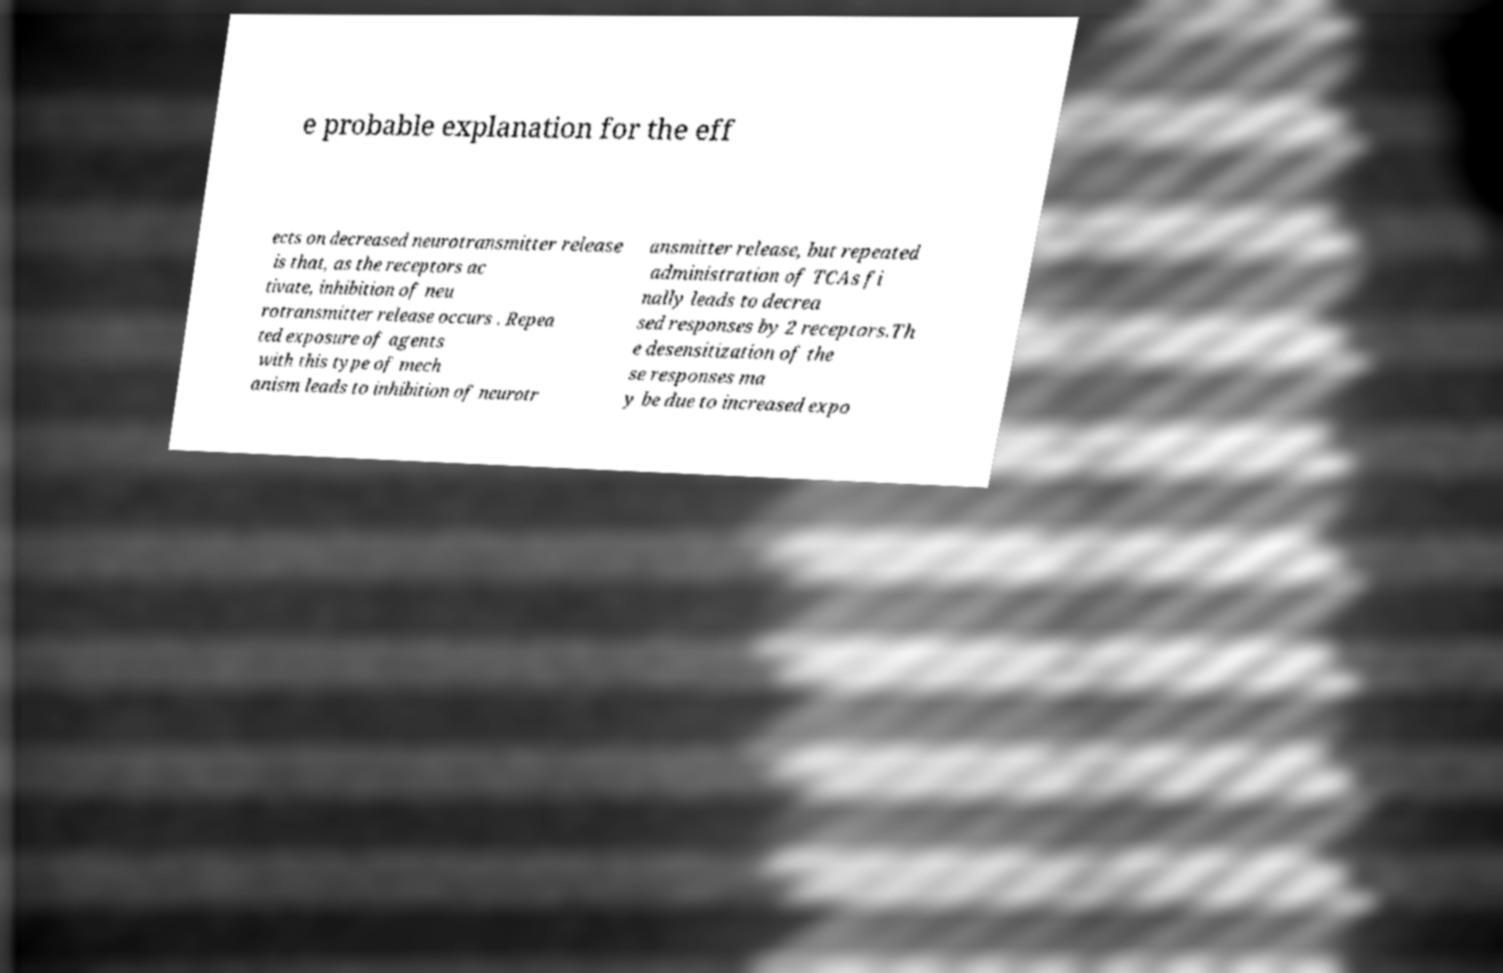Can you read and provide the text displayed in the image?This photo seems to have some interesting text. Can you extract and type it out for me? e probable explanation for the eff ects on decreased neurotransmitter release is that, as the receptors ac tivate, inhibition of neu rotransmitter release occurs . Repea ted exposure of agents with this type of mech anism leads to inhibition of neurotr ansmitter release, but repeated administration of TCAs fi nally leads to decrea sed responses by 2 receptors.Th e desensitization of the se responses ma y be due to increased expo 